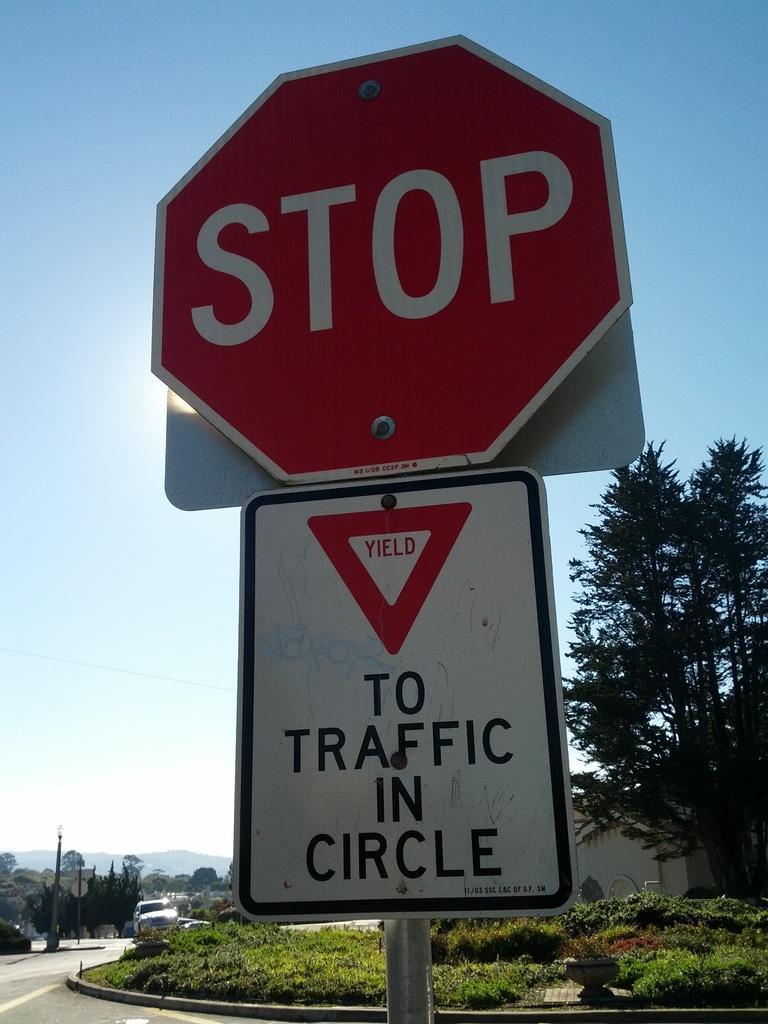Who are we yielding to?
Provide a short and direct response. Traffic in circle. What does the red sign say to do?
Provide a succinct answer. Stop. 